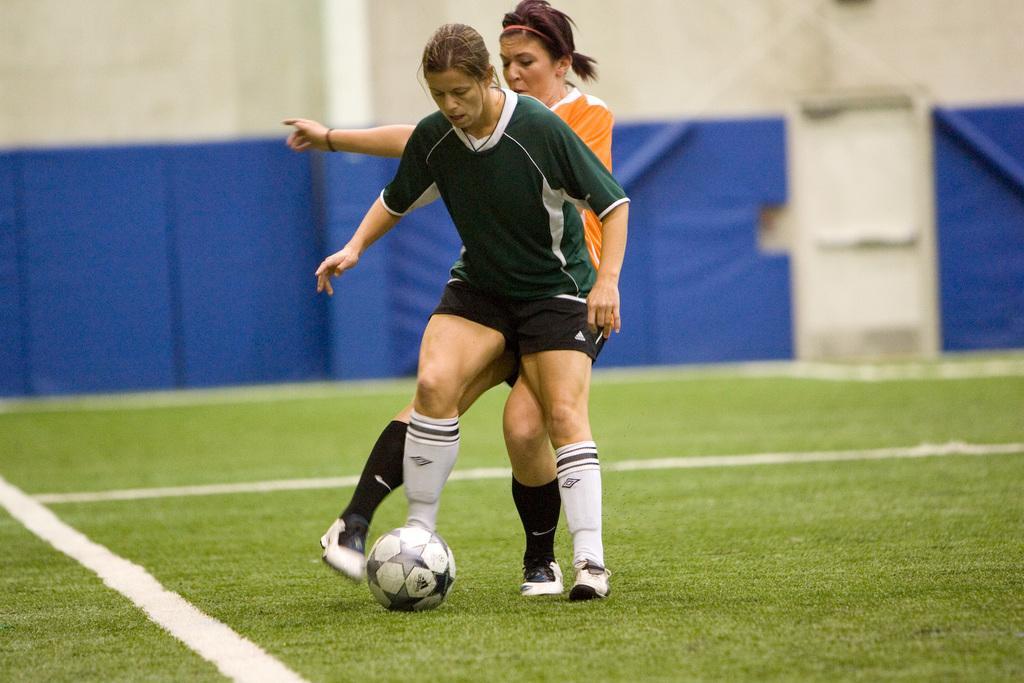Can you describe this image briefly? Two women are playing football. The woman in green is trying to kick the ball. The woman in orange is trying to avoid it. 